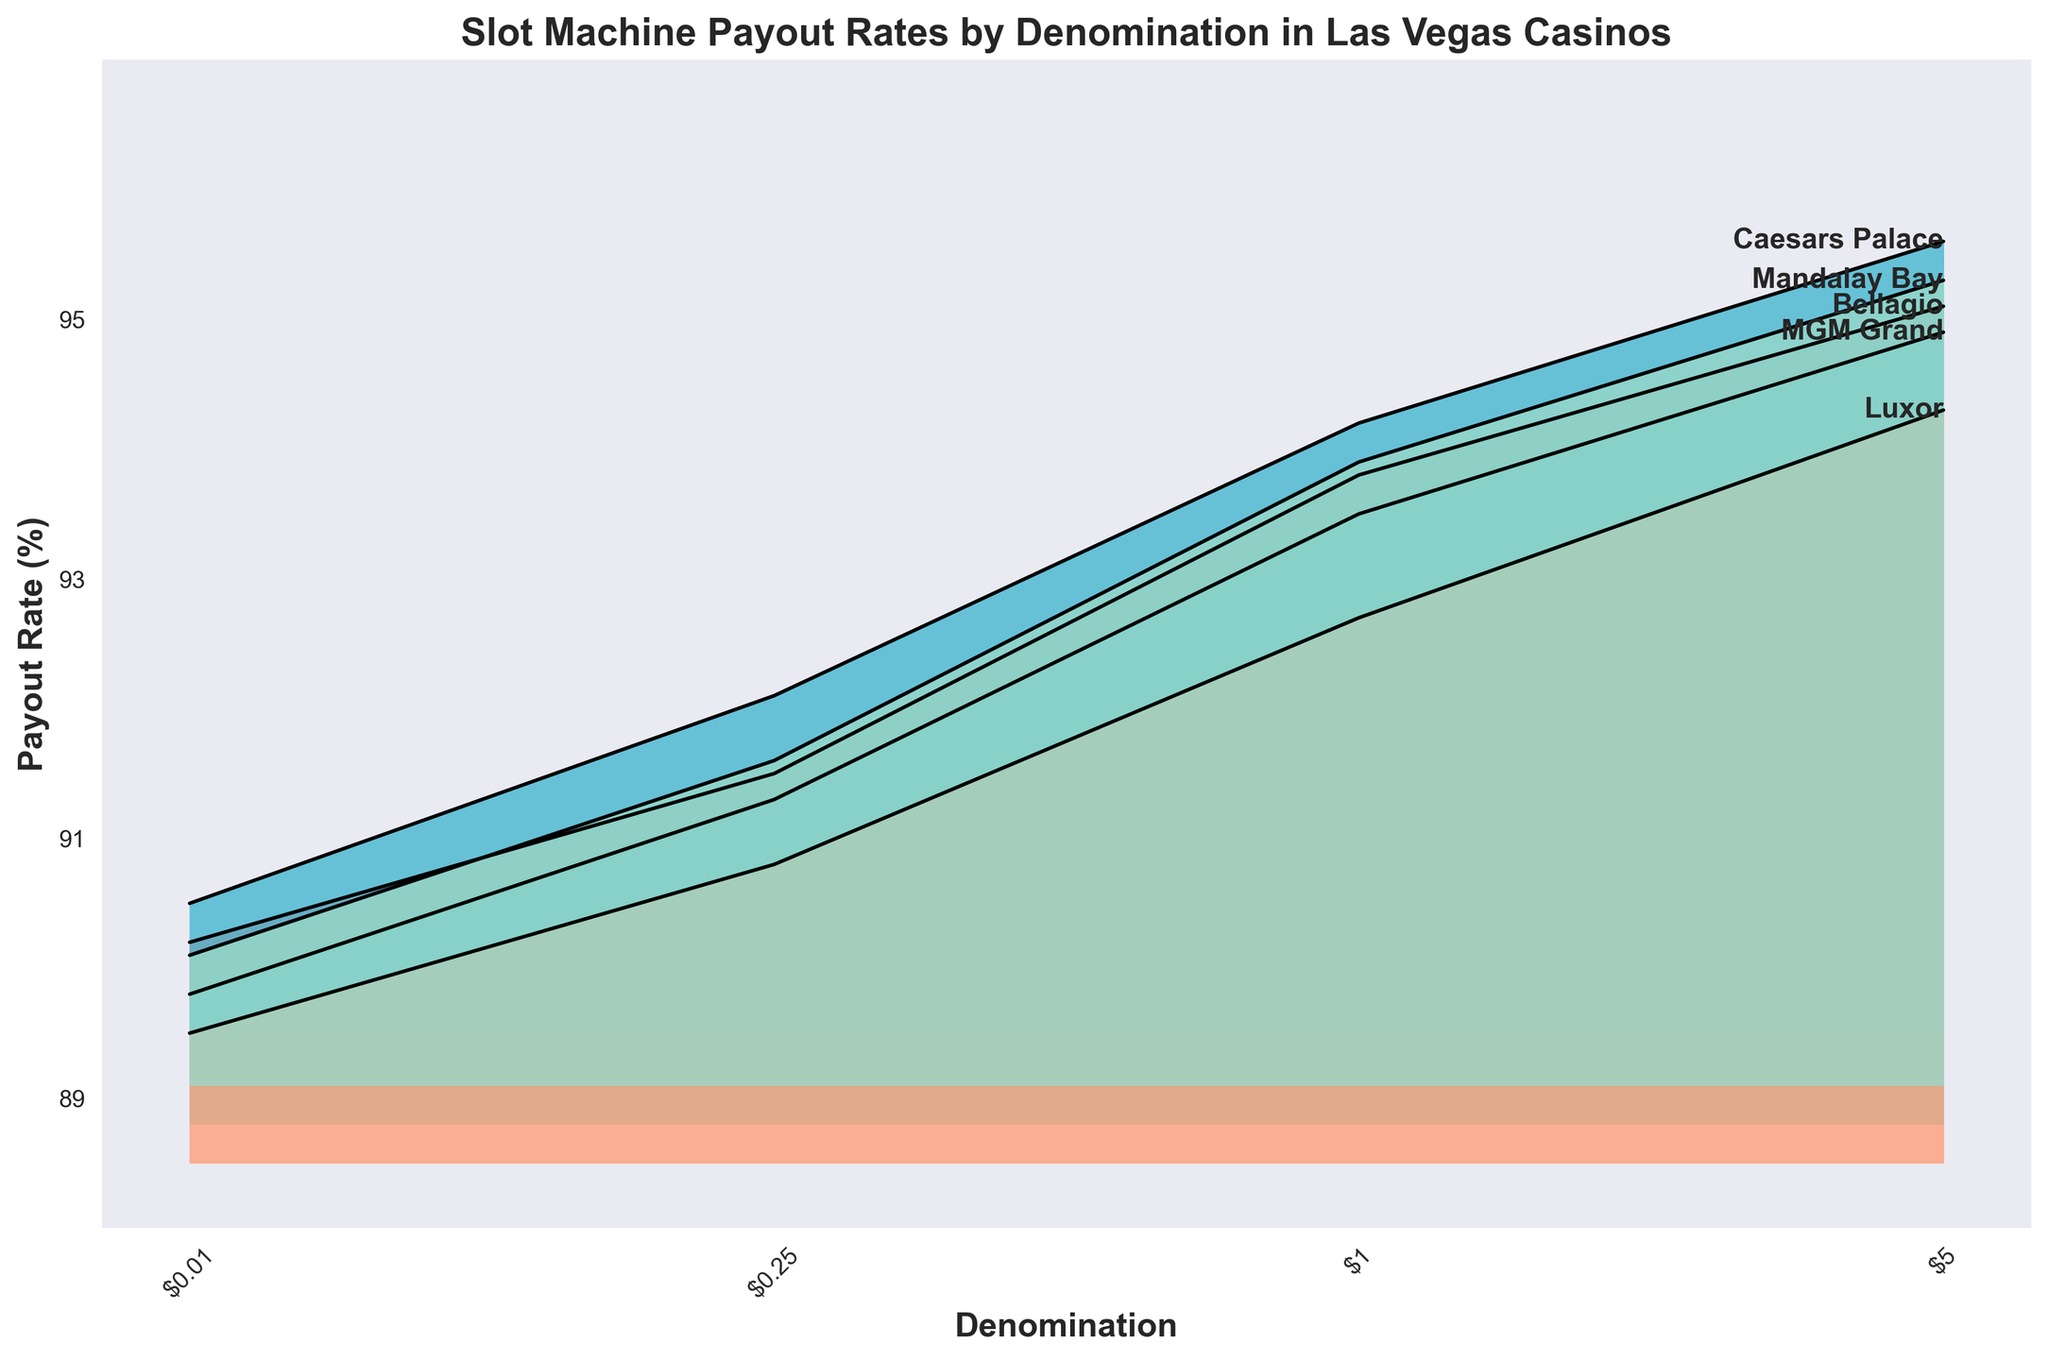What is the highest payout rate among all casinos and denominations? The highest payout rate is visible as the peak point on the highest ridge in the plot. The highest value is at Caesars Palace for the $5 denomination, which reaches a payout rate of 95.6%.
Answer: 95.6% Which casino has the lowest payout rate for the $0.01 denomination? By examining the ridges corresponding to the $0.01 denomination, the lowest point among them is at Luxor, which has a payout rate of 89.5%.
Answer: Luxor What is the approximate range of payout rates for the Bellagio? The payout rates for Bellagio for all denominations range from a minimum of 90.2% for $0.01 denomination to a maximum of 95.1% for the $5 denomination.
Answer: 90.2% to 95.1% Which denominations have a payout rate above 93% at the Mandalay Bay? For Mandalay Bay, scrutinize the heights of the ridges for different denominations. The denominations $1 and $5 are above 93%, with payout rates of 93.9% and 95.3%, respectively.
Answer: $1, $5 What is the average payout rate for Caesars Palace across all denominations? Calculate the sum of the payout rates for Caesars Palace (90.5 + 92.1 + 94.2 + 95.6 = 372.4) and divide by the number of denominations (4). The average payout rate is 93.1%.
Answer: 93.1% Which casino consistently has the highest payout rates across all denominations? By comparing ridges visually, Caesars Palace generally has higher or equal payout rates as compared to other casinos for most denominations. Therefore, the peak positions of Caesars Palace show that it consistently has the highest rates.
Answer: Caesars Palace How does the payout rate for the $1 denomination at MGM Grand compare to Bellagio? For the $1 denomination, the ridges indicate that MGM Grand has a payout rate of 93.5%, whereas Bellagio has 93.8%. Therefore, Bellagio's rate is slightly higher.
Answer: Bellagio’s rate is higher Is there a general trend in payout rates as denomination increases? Across all casinos, the ridges show a general upward trend in payout rates as the denomination increases, suggesting higher denominations have higher payout rates.
Answer: Yes How many casinos are displayed in the plot? The legend or labels along the ridges identify the different casinos. Counting them, there are five casinos: Bellagio, MGM Grand, Caesars Palace, Luxor, and Mandalay Bay.
Answer: 5 What is the payout rate at Mandalay Bay for the $0.25 denomination? Looking at the ridge for Mandalay Bay at the $0.25 mark on the x-axis, the payout rate is listed as 91.6%.
Answer: 91.6% 